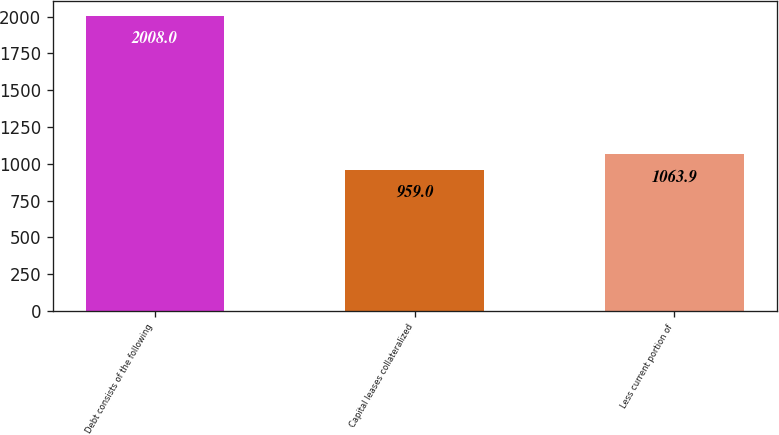Convert chart to OTSL. <chart><loc_0><loc_0><loc_500><loc_500><bar_chart><fcel>Debt consists of the following<fcel>Capital leases collateralized<fcel>Less current portion of<nl><fcel>2008<fcel>959<fcel>1063.9<nl></chart> 